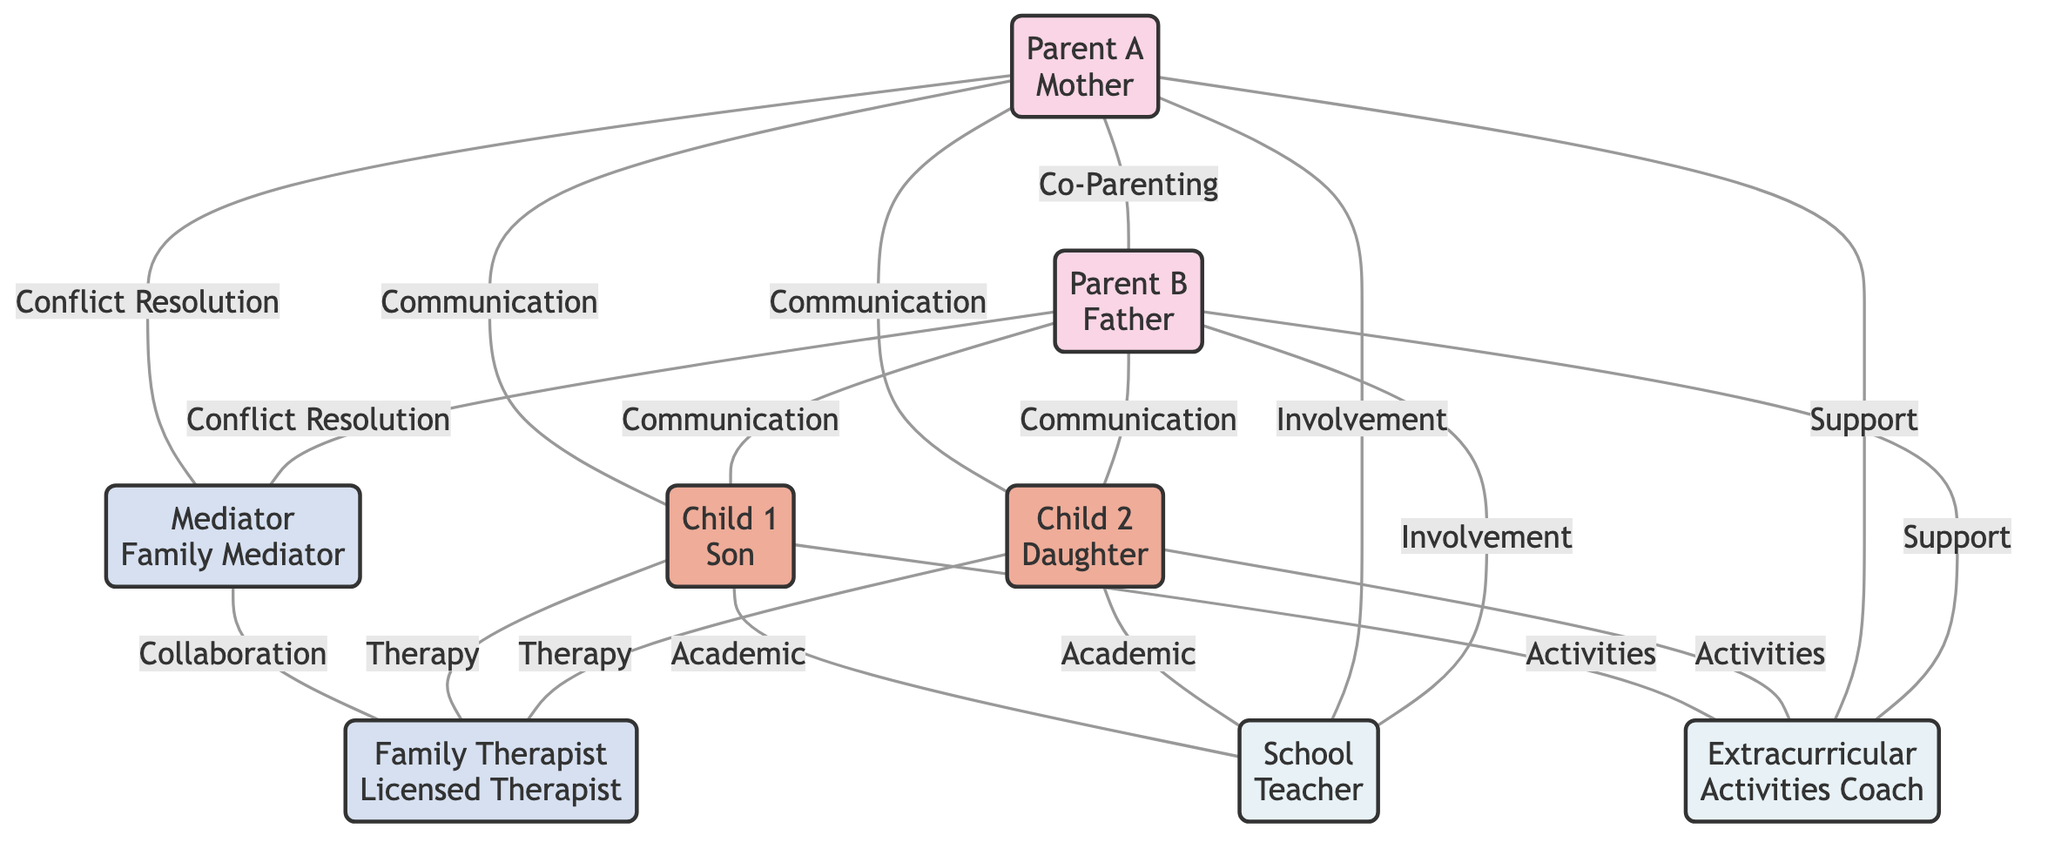What is the role of 'parent1'? In the diagram, 'parent1' is labeled as 'Parent A' and is identified as the 'Mother.'
Answer: Mother How many children are represented in the diagram? The diagram shows two nodes labeled 'Child 1' and 'Child 2,' indicating that there are two children represented.
Answer: 2 What is the relationship labeled between 'parent1' and 'parent2'? The link connecting 'parent1' to 'parent2' is labeled 'Co-Parenting Relationship,' indicating the type of relationship they share.
Answer: Co-Parenting Relationship Which nodes are connected to the 'mediator'? The 'mediator' is linked to 'parent1' and 'parent2' with the label 'Conflict Resolution,' and is also connected to 'therapist' with the label 'Collaboration.'
Answer: parent1, parent2, therapist What type of communication exists between 'parent2' and 'child2'? The link between 'parent2' and 'child2' is labeled 'Parent-Child Communication,' showing the nature of interactions they share.
Answer: Parent-Child Communication How many professional roles are depicted in the diagram? There are two nodes labeled as professionals: 'Mediator' and 'Family Therapist.' This indicates that there are two distinct professional roles.
Answer: 2 Which child participates in therapy sessions? Both 'Child 1' and 'Child 2' have links to the 'therapist' with the label 'Therapy Sessions,' indicating both participate in therapy.
Answer: Child 1, Child 2 What is the label of the link between 'child1' and 'school'? The link between 'child1' and 'school' is labeled 'Academic Collaboration,' indicating the relationship based on educational involvement.
Answer: Academic Collaboration Which nodes are connected to 'extracurricular' activities? 'Child 1' and 'Child 2' are linked to 'extracurricular' with the label 'Activity Participation,' while 'parent1' and 'parent2' are linked with the label 'Parental Support.'
Answer: Child 1, Child 2, parent1, parent2 What is the purpose of the links from parents to the 'mediator'? The links from 'parent1' and 'parent2' to the 'mediator' are labeled 'Conflict Resolution,' indicating that their purpose is to assist in resolving conflicts.
Answer: Conflict Resolution 